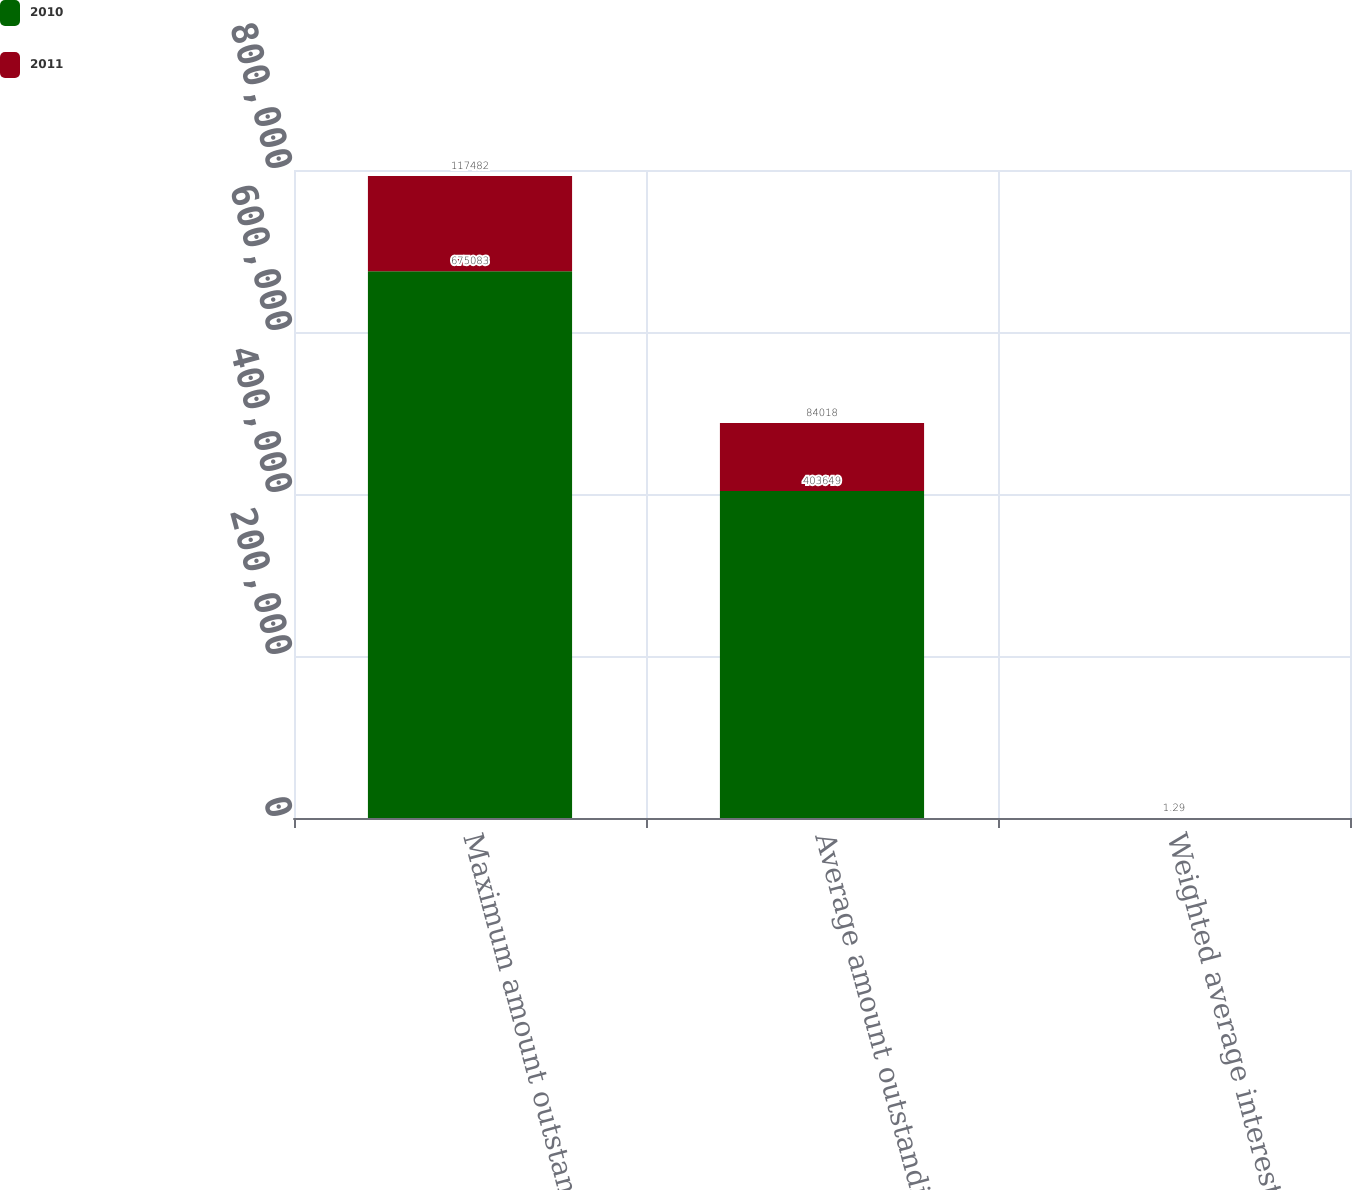Convert chart. <chart><loc_0><loc_0><loc_500><loc_500><stacked_bar_chart><ecel><fcel>Maximum amount outstanding at<fcel>Average amount outstanding<fcel>Weighted average interest rate<nl><fcel>2010<fcel>675083<fcel>403649<fcel>1.81<nl><fcel>2011<fcel>117482<fcel>84018<fcel>1.29<nl></chart> 